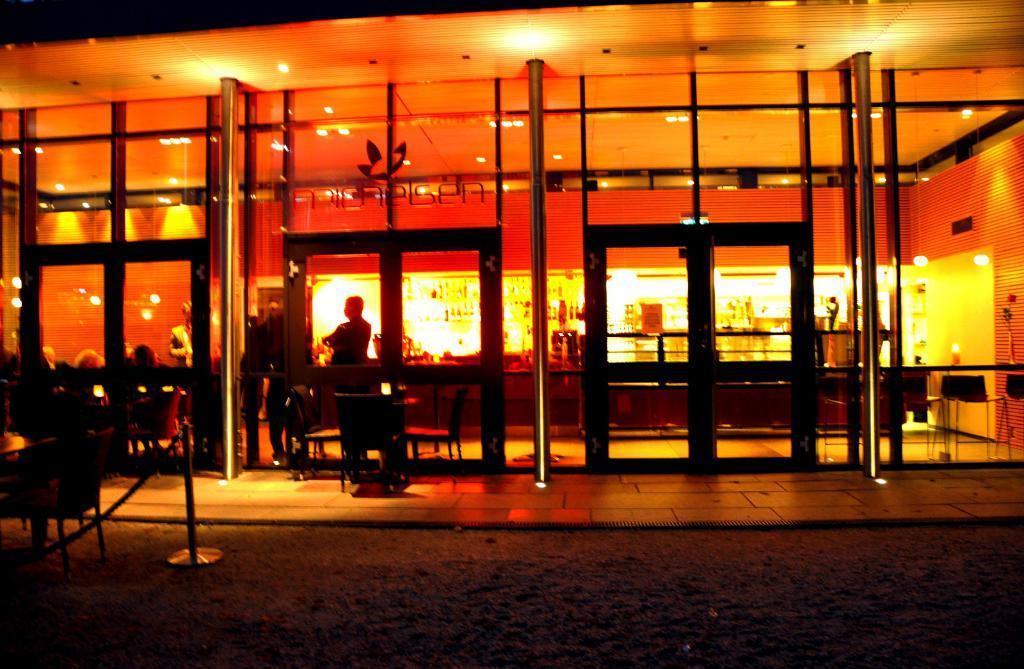Please provide a concise description of this image. In this picture we can see sand, rope, poles, chair and glass, through this glass we can see people, chairs and lights. In the background of the image it is not clear and we can see objects. 